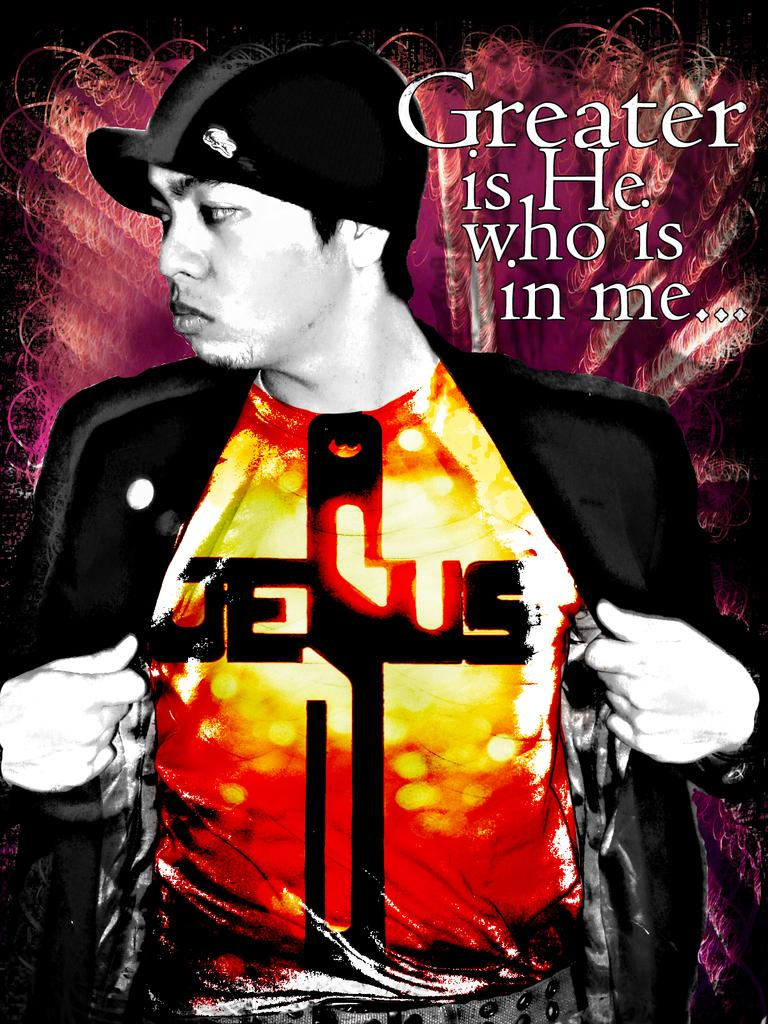<image>
Share a concise interpretation of the image provided. A man wearing a Jesus shirt with the words Greater is he who is in me displayed next to him. 